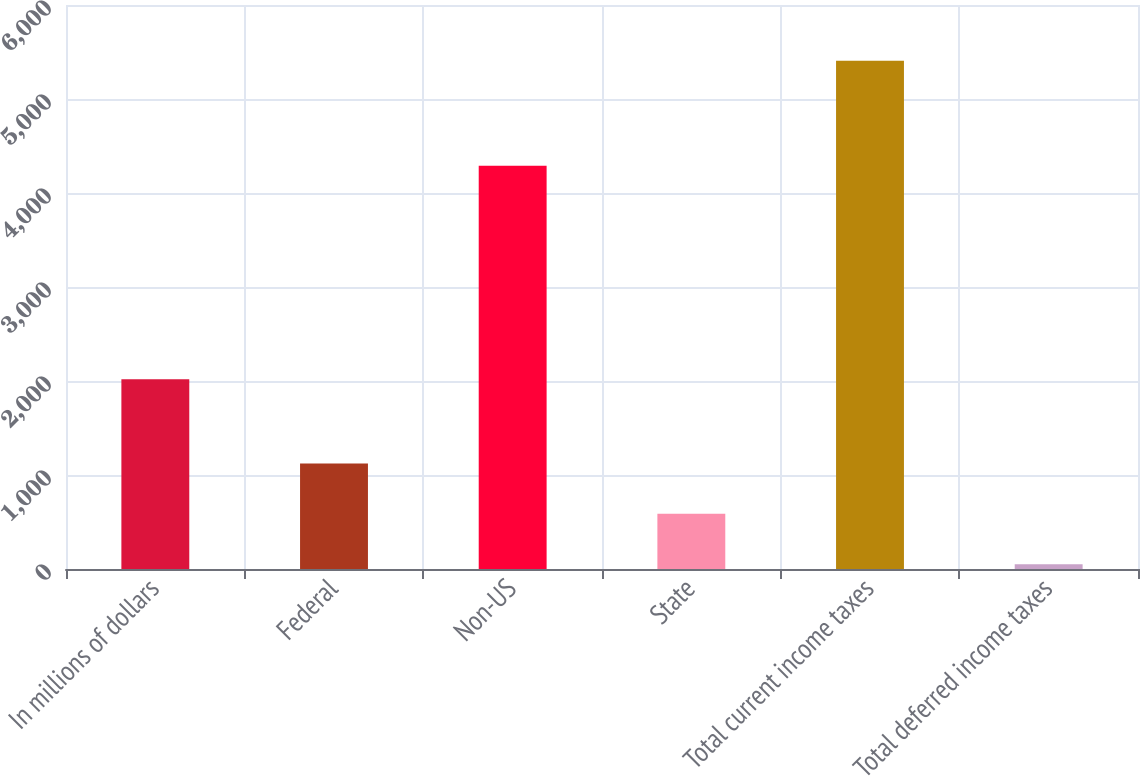Convert chart to OTSL. <chart><loc_0><loc_0><loc_500><loc_500><bar_chart><fcel>In millions of dollars<fcel>Federal<fcel>Non-US<fcel>State<fcel>Total current income taxes<fcel>Total deferred income taxes<nl><fcel>2018<fcel>1122.4<fcel>4290<fcel>586.7<fcel>5408<fcel>51<nl></chart> 